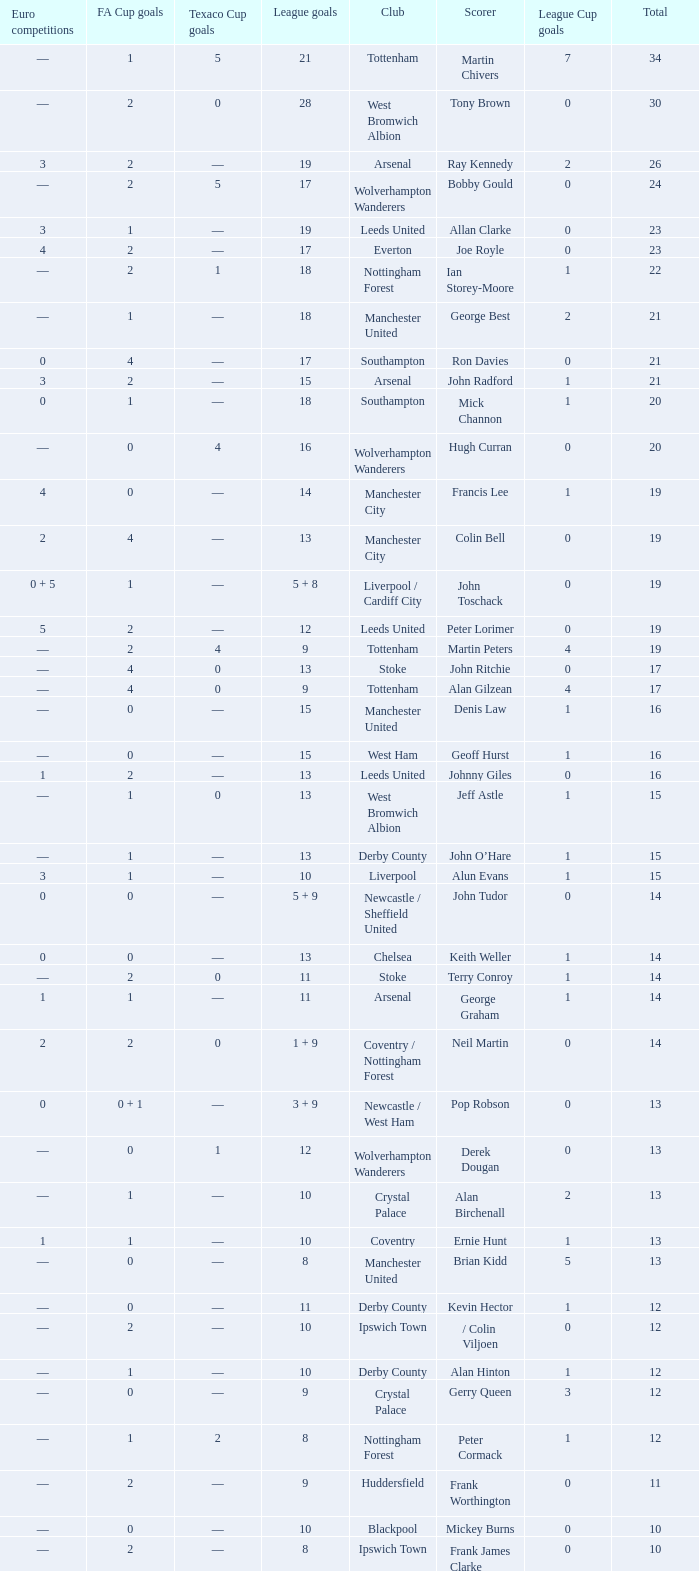What is FA Cup Goals, when Euro Competitions is 1, and when League Goals is 11? 1.0. 